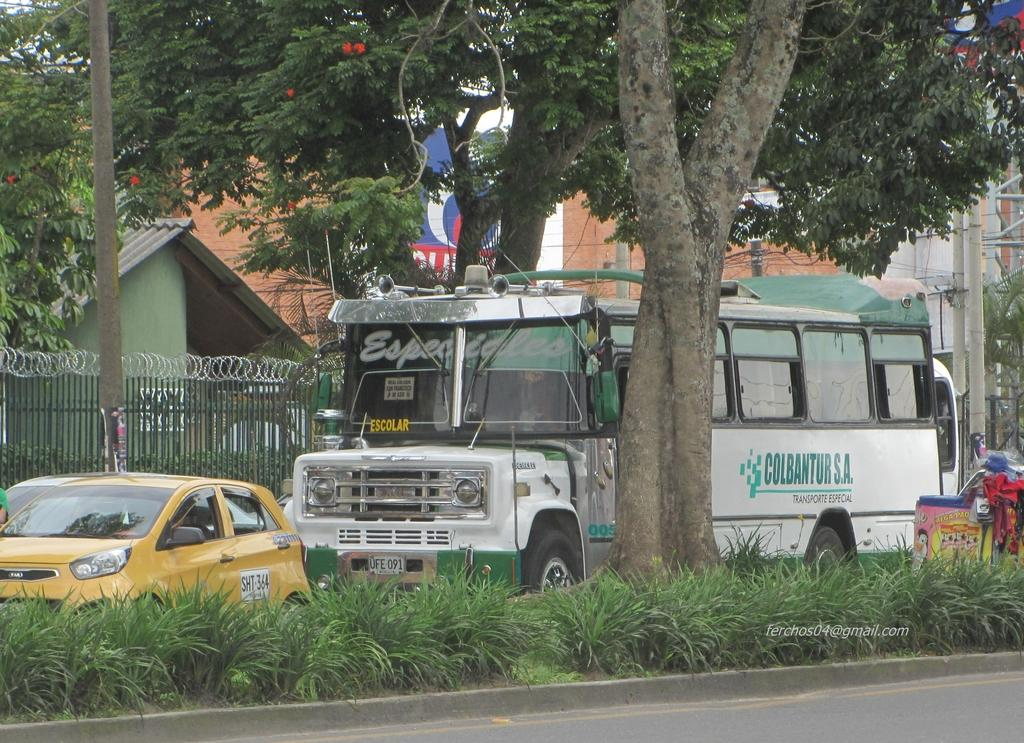What type of structures can be seen in the image? There are buildings in the image. What else can be seen moving in the image? There are vehicles in the image. What type of natural elements are present in the image? There are trees and plants in the image. What are the vertical structures in the image used for? There are poles in the image, which may be used for supporting wires. What are the wires used for in the image? The wires in the image may be used for transmitting electricity or communication signals. What type of barrier is present in the image? There is a fencing in the image. What type of signage is present in the image? There is a poster with text in the image. What type of loaf is being prepared by the mother in the image? There is no mother or loaf present in the image. What time of day is depicted in the image? The time of day is not mentioned in the provided facts, so it cannot be determined from the image. 